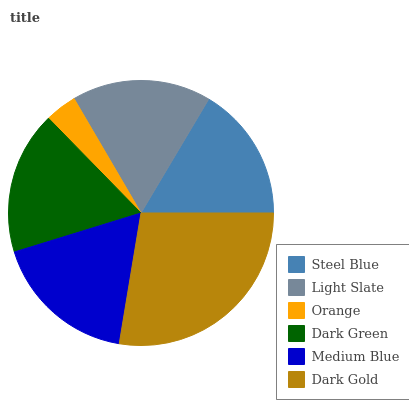Is Orange the minimum?
Answer yes or no. Yes. Is Dark Gold the maximum?
Answer yes or no. Yes. Is Light Slate the minimum?
Answer yes or no. No. Is Light Slate the maximum?
Answer yes or no. No. Is Light Slate greater than Steel Blue?
Answer yes or no. Yes. Is Steel Blue less than Light Slate?
Answer yes or no. Yes. Is Steel Blue greater than Light Slate?
Answer yes or no. No. Is Light Slate less than Steel Blue?
Answer yes or no. No. Is Dark Green the high median?
Answer yes or no. Yes. Is Light Slate the low median?
Answer yes or no. Yes. Is Steel Blue the high median?
Answer yes or no. No. Is Dark Gold the low median?
Answer yes or no. No. 